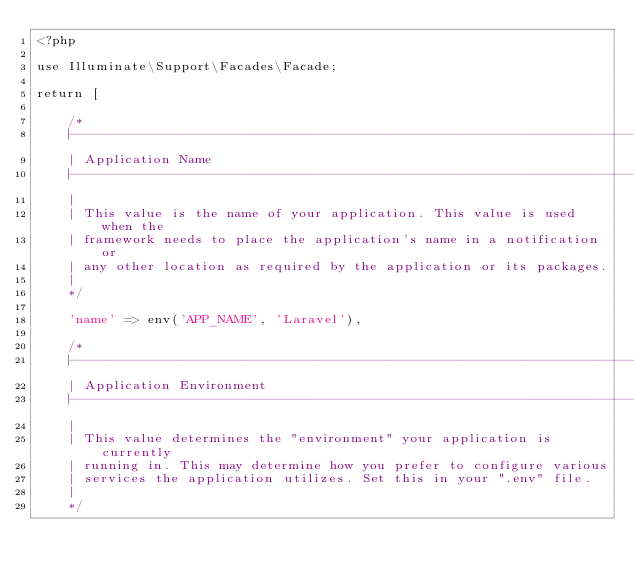Convert code to text. <code><loc_0><loc_0><loc_500><loc_500><_PHP_><?php

use Illuminate\Support\Facades\Facade;

return [

    /*
    |--------------------------------------------------------------------------
    | Application Name
    |--------------------------------------------------------------------------
    |
    | This value is the name of your application. This value is used when the
    | framework needs to place the application's name in a notification or
    | any other location as required by the application or its packages.
    |
    */

    'name' => env('APP_NAME', 'Laravel'),

    /*
    |--------------------------------------------------------------------------
    | Application Environment
    |--------------------------------------------------------------------------
    |
    | This value determines the "environment" your application is currently
    | running in. This may determine how you prefer to configure various
    | services the application utilizes. Set this in your ".env" file.
    |
    */
</code> 